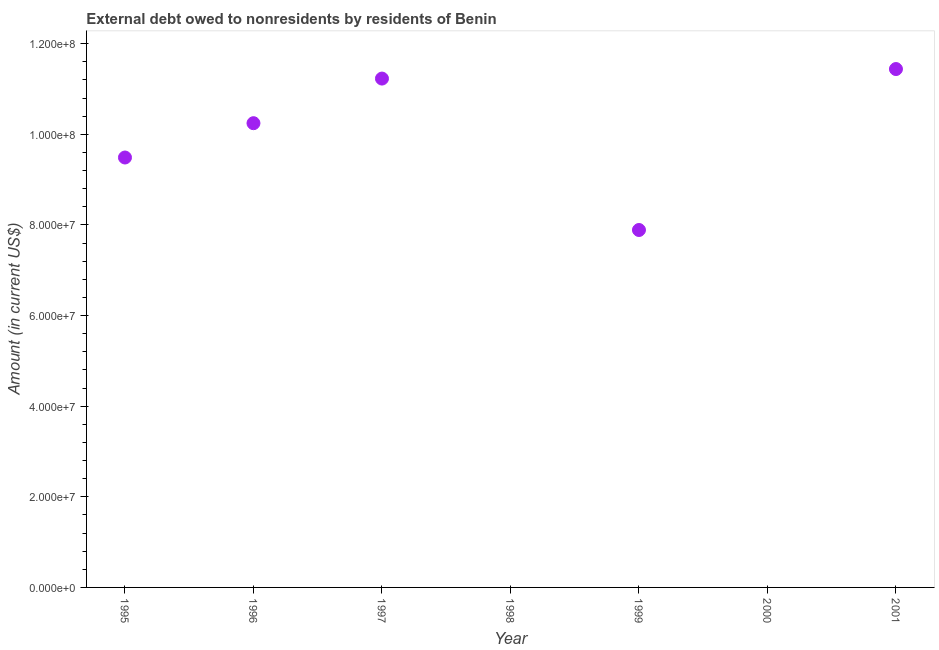Across all years, what is the maximum debt?
Keep it short and to the point. 1.14e+08. In which year was the debt maximum?
Your answer should be very brief. 2001. What is the sum of the debt?
Ensure brevity in your answer.  5.03e+08. What is the difference between the debt in 1995 and 1999?
Your response must be concise. 1.60e+07. What is the average debt per year?
Your response must be concise. 7.18e+07. What is the median debt?
Your answer should be compact. 9.49e+07. What is the ratio of the debt in 1996 to that in 2001?
Provide a short and direct response. 0.9. Is the difference between the debt in 1995 and 1999 greater than the difference between any two years?
Ensure brevity in your answer.  No. What is the difference between the highest and the second highest debt?
Make the answer very short. 2.10e+06. Is the sum of the debt in 1995 and 1997 greater than the maximum debt across all years?
Ensure brevity in your answer.  Yes. What is the difference between the highest and the lowest debt?
Keep it short and to the point. 1.14e+08. In how many years, is the debt greater than the average debt taken over all years?
Your response must be concise. 5. What is the difference between two consecutive major ticks on the Y-axis?
Offer a very short reply. 2.00e+07. What is the title of the graph?
Provide a short and direct response. External debt owed to nonresidents by residents of Benin. What is the label or title of the Y-axis?
Provide a short and direct response. Amount (in current US$). What is the Amount (in current US$) in 1995?
Your response must be concise. 9.49e+07. What is the Amount (in current US$) in 1996?
Provide a short and direct response. 1.02e+08. What is the Amount (in current US$) in 1997?
Offer a terse response. 1.12e+08. What is the Amount (in current US$) in 1998?
Keep it short and to the point. 0. What is the Amount (in current US$) in 1999?
Offer a very short reply. 7.89e+07. What is the Amount (in current US$) in 2000?
Your answer should be compact. 0. What is the Amount (in current US$) in 2001?
Ensure brevity in your answer.  1.14e+08. What is the difference between the Amount (in current US$) in 1995 and 1996?
Offer a very short reply. -7.57e+06. What is the difference between the Amount (in current US$) in 1995 and 1997?
Your response must be concise. -1.74e+07. What is the difference between the Amount (in current US$) in 1995 and 1999?
Your response must be concise. 1.60e+07. What is the difference between the Amount (in current US$) in 1995 and 2001?
Offer a very short reply. -1.95e+07. What is the difference between the Amount (in current US$) in 1996 and 1997?
Provide a short and direct response. -9.84e+06. What is the difference between the Amount (in current US$) in 1996 and 1999?
Give a very brief answer. 2.36e+07. What is the difference between the Amount (in current US$) in 1996 and 2001?
Make the answer very short. -1.19e+07. What is the difference between the Amount (in current US$) in 1997 and 1999?
Give a very brief answer. 3.34e+07. What is the difference between the Amount (in current US$) in 1997 and 2001?
Give a very brief answer. -2.10e+06. What is the difference between the Amount (in current US$) in 1999 and 2001?
Offer a terse response. -3.55e+07. What is the ratio of the Amount (in current US$) in 1995 to that in 1996?
Your response must be concise. 0.93. What is the ratio of the Amount (in current US$) in 1995 to that in 1997?
Keep it short and to the point. 0.84. What is the ratio of the Amount (in current US$) in 1995 to that in 1999?
Give a very brief answer. 1.2. What is the ratio of the Amount (in current US$) in 1995 to that in 2001?
Keep it short and to the point. 0.83. What is the ratio of the Amount (in current US$) in 1996 to that in 1997?
Give a very brief answer. 0.91. What is the ratio of the Amount (in current US$) in 1996 to that in 1999?
Provide a succinct answer. 1.3. What is the ratio of the Amount (in current US$) in 1996 to that in 2001?
Your answer should be compact. 0.9. What is the ratio of the Amount (in current US$) in 1997 to that in 1999?
Provide a succinct answer. 1.42. What is the ratio of the Amount (in current US$) in 1997 to that in 2001?
Provide a short and direct response. 0.98. What is the ratio of the Amount (in current US$) in 1999 to that in 2001?
Keep it short and to the point. 0.69. 